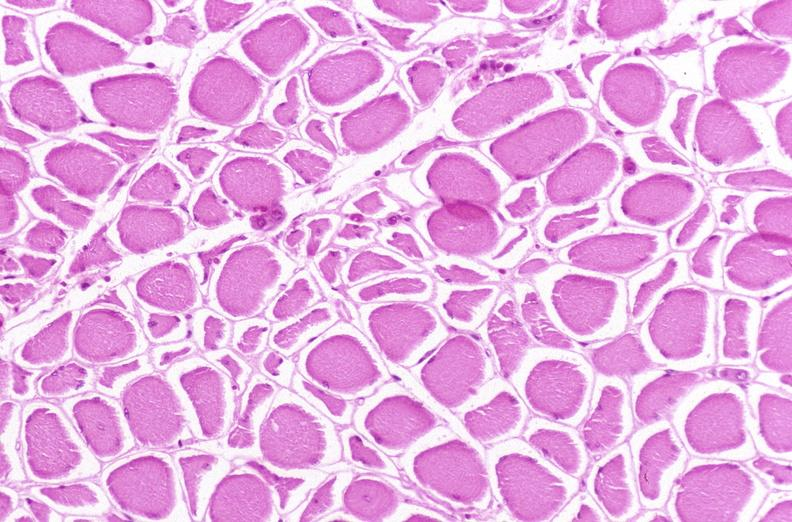why does this image show skeletal muscle, atrophy?
Answer the question using a single word or phrase. Due to immobilization cast 